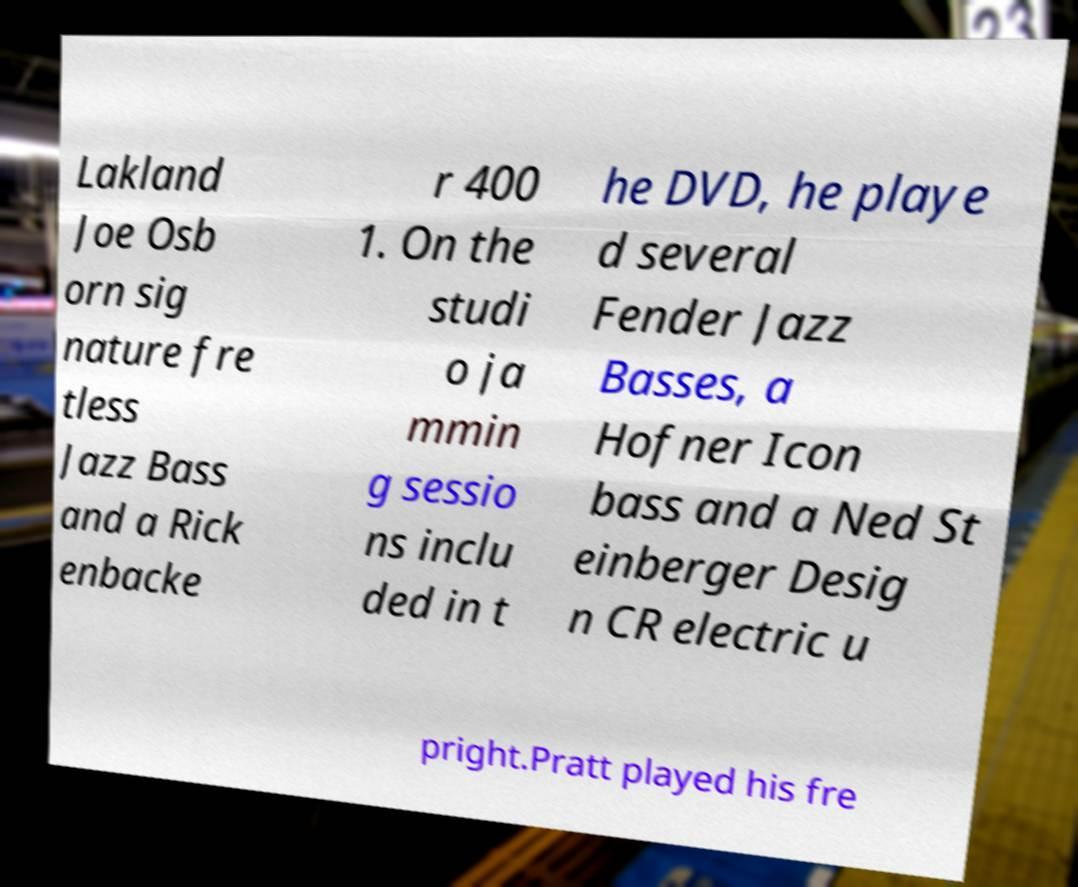Please identify and transcribe the text found in this image. Lakland Joe Osb orn sig nature fre tless Jazz Bass and a Rick enbacke r 400 1. On the studi o ja mmin g sessio ns inclu ded in t he DVD, he playe d several Fender Jazz Basses, a Hofner Icon bass and a Ned St einberger Desig n CR electric u pright.Pratt played his fre 